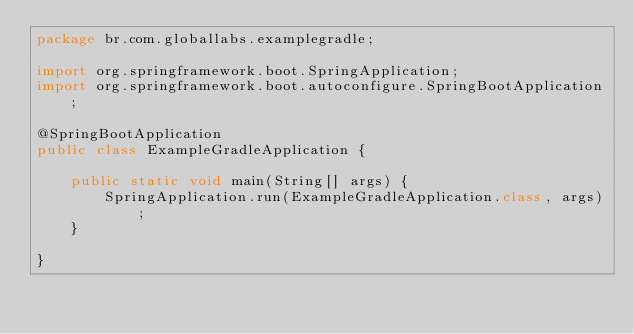<code> <loc_0><loc_0><loc_500><loc_500><_Java_>package br.com.globallabs.examplegradle;

import org.springframework.boot.SpringApplication;
import org.springframework.boot.autoconfigure.SpringBootApplication;

@SpringBootApplication
public class ExampleGradleApplication {

	public static void main(String[] args) {
		SpringApplication.run(ExampleGradleApplication.class, args);
	}

}
</code> 